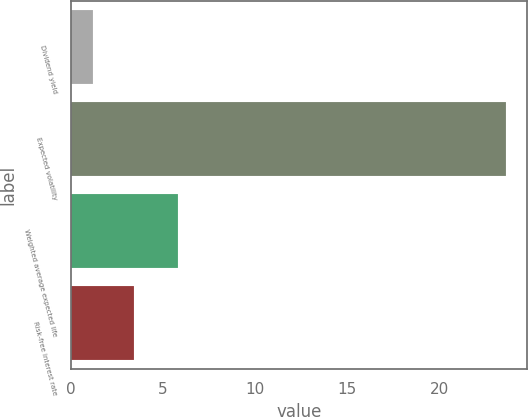Convert chart to OTSL. <chart><loc_0><loc_0><loc_500><loc_500><bar_chart><fcel>Dividend yield<fcel>Expected volatility<fcel>Weighted average expected life<fcel>Risk-free interest rate<nl><fcel>1.2<fcel>23.6<fcel>5.8<fcel>3.44<nl></chart> 